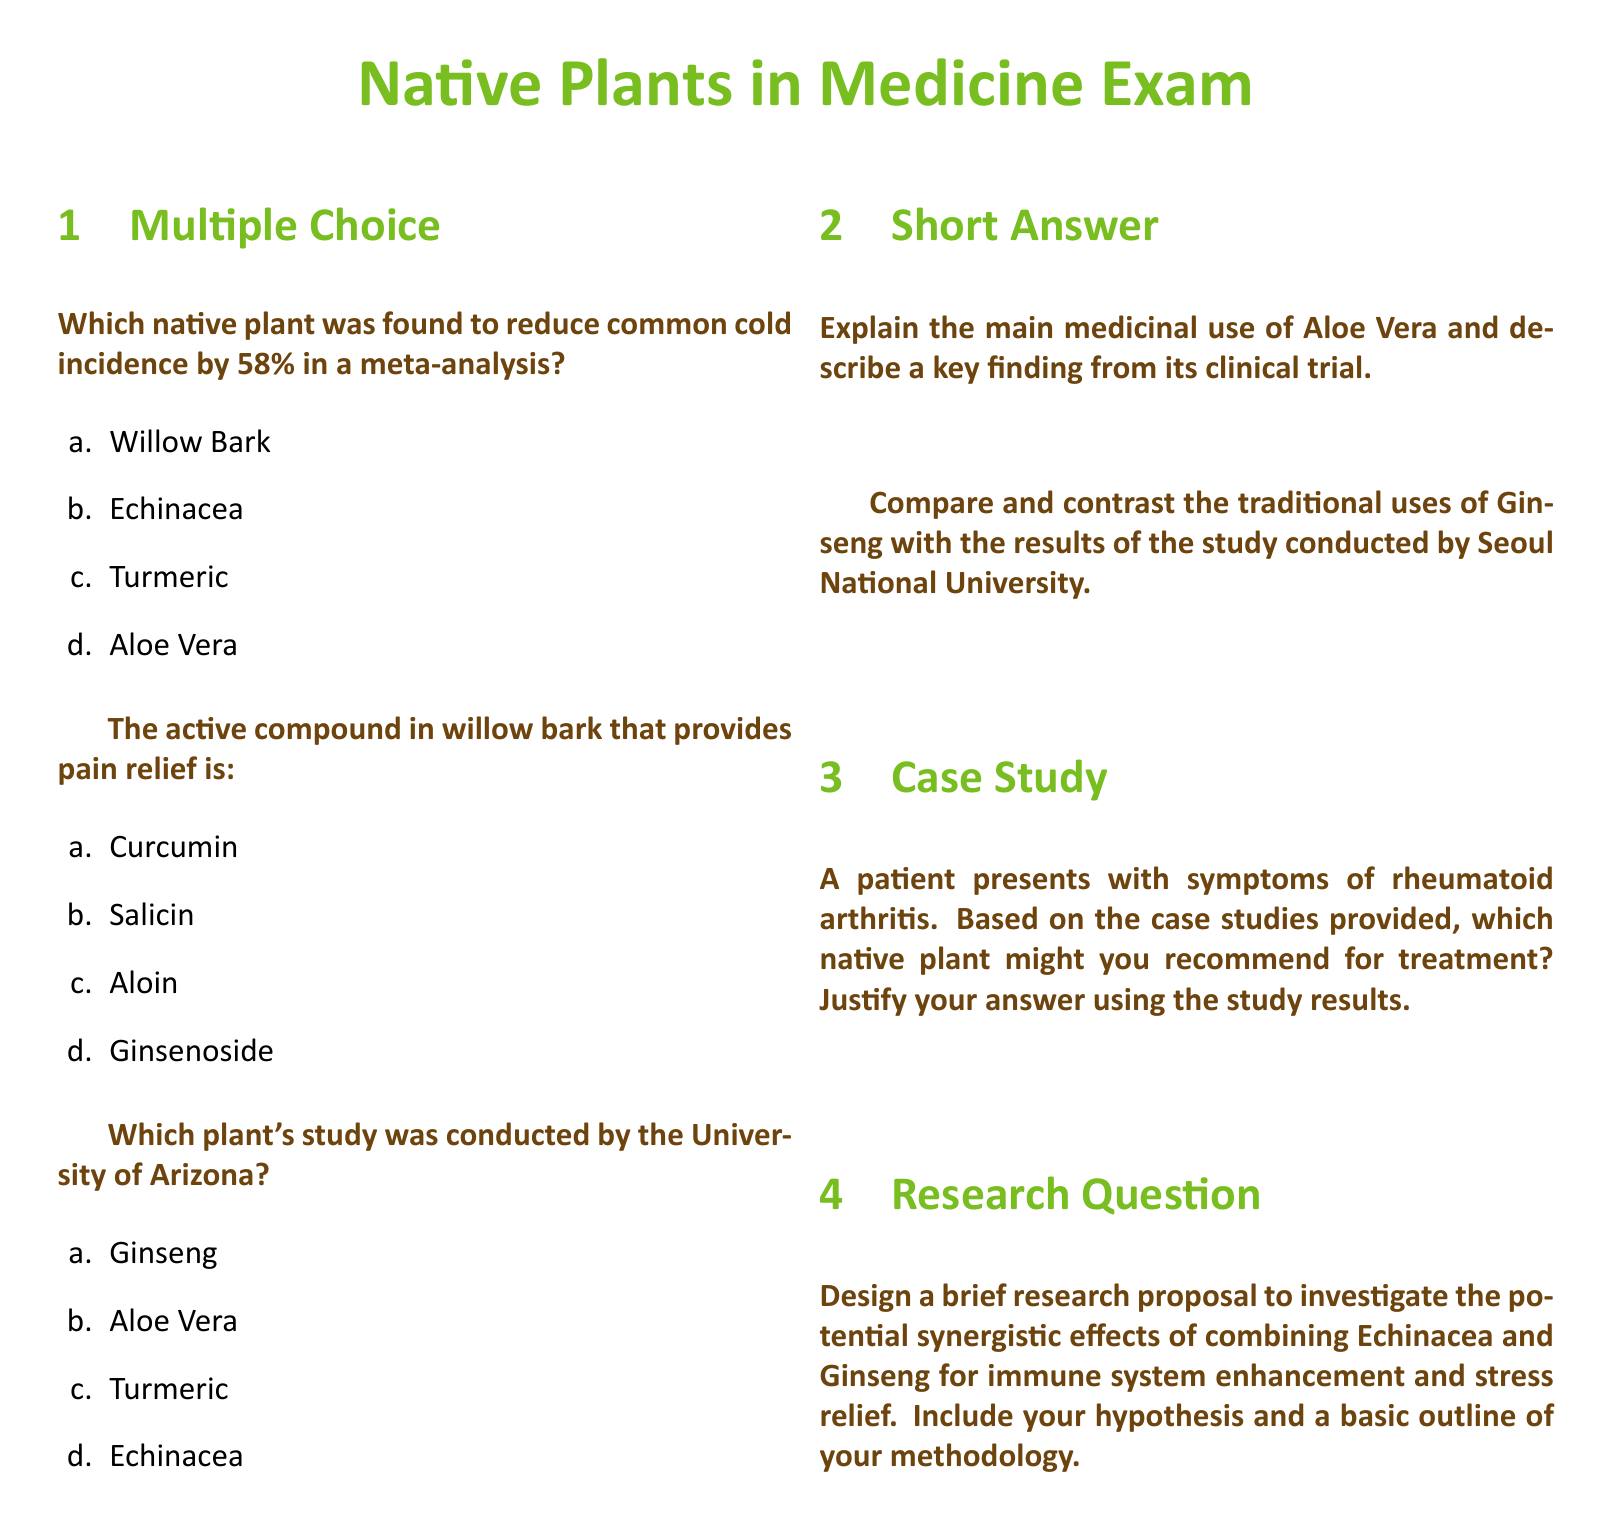What native plant was found to reduce common cold incidence by 58%? This information is explicitly stated in the multiple-choice section of the document.
Answer: Echinacea What is the active compound in willow bark? The document clearly specifies the active compound in willow bark in the multiple-choice section.
Answer: Salicin Which plant's study was conducted by the University of Arizona? The document mentions the specific study conducted by the University of Arizona in the multiple-choice section.
Answer: Aloe Vera What is the main medicinal use of Aloe Vera? This information is requested in the short answer section of the document.
Answer: Skin healing What were the traditional uses of Ginseng? The document specifies that Ginseng has traditional uses that need to be compared with study results.
Answer: Energy and vitality Which native plant might you recommend for rheumatoid arthritis treatment? This is a reasoning question based on the case studies discussed in the document.
Answer: Ginseng What is the research question proposed in relation to Echinacea and Ginseng? The document outlines a research proposal in the short answer section regarding their combined effects.
Answer: Synergistic effects How much was the reduction in common cold incidence by Echinacea? This question retrieves a specific numerical value from the document.
Answer: 58% What is the hypothesis of the proposed research study in the document? The document requires a brief research proposal which includes a hypothesis related to Echinacea and Ginseng.
Answer: Immune system enhancement and stress relief 